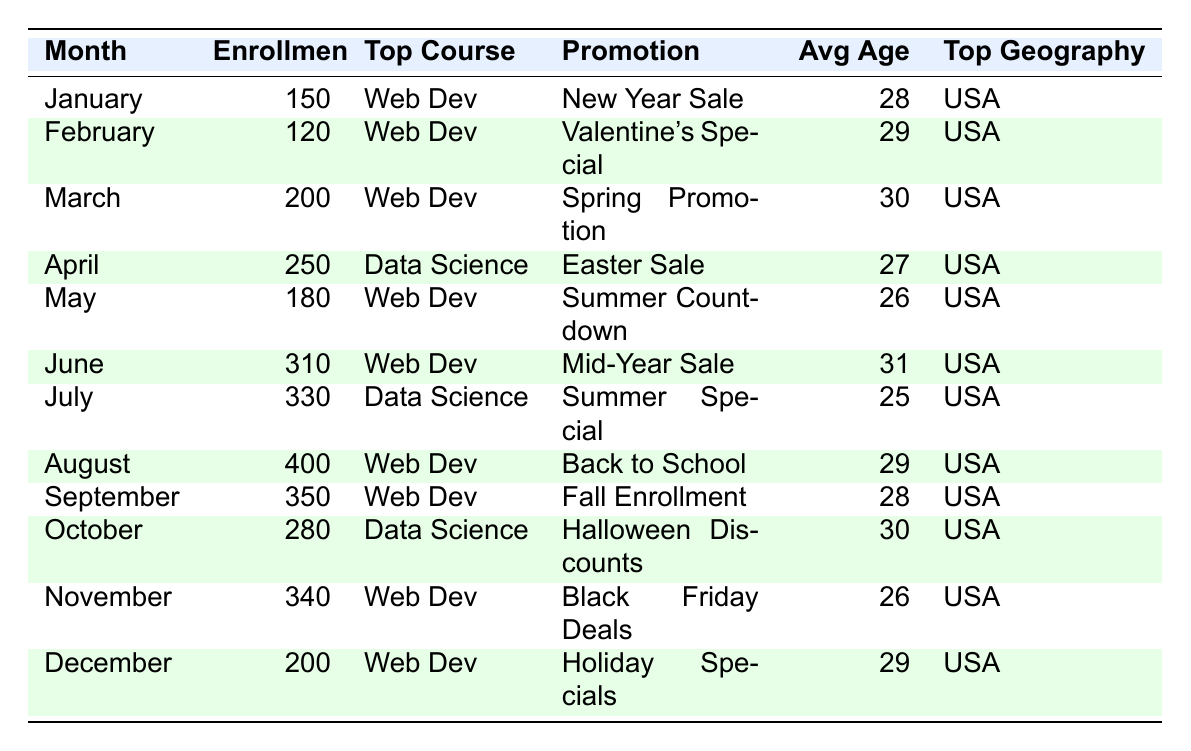What was the total number of enrollments in July and August? The number of enrollments in July is 330 and in August is 400. Adding these gives 330 + 400 = 730.
Answer: 730 Which month had the highest number of enrollments? The highest number of enrollments is in August, with 400 enrollments.
Answer: August Was the average age of students in June higher than in May? The average age in June is 31 and in May is 26. Since 31 > 26, June's average age is higher.
Answer: Yes What course was most popular in October? The top course in October is Data Science, as listed in the table.
Answer: Data Science How many enrollments were recorded during the Easter Sale in April? The enrollments during the Easter Sale in April were 250, as noted in the table.
Answer: 250 What is the difference in enrollments between January and March? In January, there were 150 enrollments, and in March, there were 200. The difference is 200 - 150 = 50.
Answer: 50 Did more students enroll in September than in November? September had 350 enrollments while November had 340. Since 350 > 340, more students enrolled in September.
Answer: Yes Which promotion was used in connection with the most enrollments? The August promotion "Back to School" had the most enrollments at 400.
Answer: Back to School What was the average enrollment for the last quarter (October, November, December)? The enrollments for these months are 280, 340, and 200. The average is (280 + 340 + 200) / 3 = 273.33, rounded gives 273.
Answer: 273 In what months did the average age fall below 30? The average age fell below 30 in January (28), April (27), May (26), July (25), and November (26).
Answer: January, April, May, July, November 